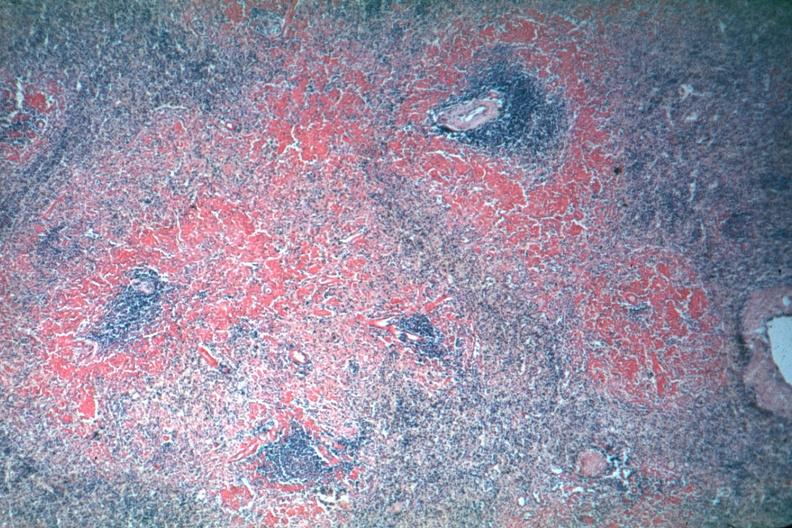what is present?
Answer the question using a single word or phrase. Spleen 